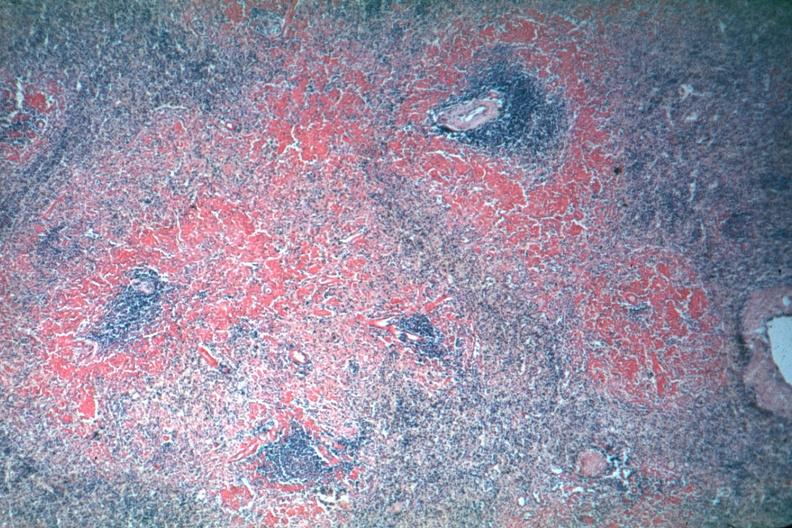what is present?
Answer the question using a single word or phrase. Spleen 